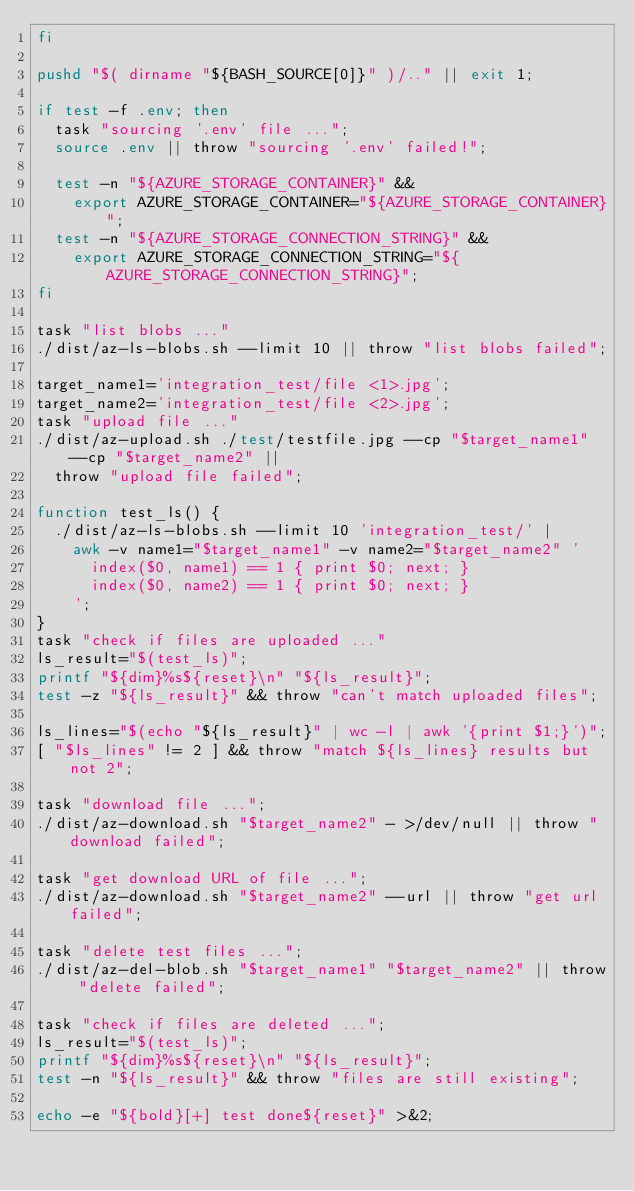Convert code to text. <code><loc_0><loc_0><loc_500><loc_500><_Bash_>fi

pushd "$( dirname "${BASH_SOURCE[0]}" )/.." || exit 1;

if test -f .env; then
  task "sourcing '.env' file ...";
  source .env || throw "sourcing '.env' failed!";

  test -n "${AZURE_STORAGE_CONTAINER}" &&
    export AZURE_STORAGE_CONTAINER="${AZURE_STORAGE_CONTAINER}";
  test -n "${AZURE_STORAGE_CONNECTION_STRING}" &&
    export AZURE_STORAGE_CONNECTION_STRING="${AZURE_STORAGE_CONNECTION_STRING}";
fi

task "list blobs ..."
./dist/az-ls-blobs.sh --limit 10 || throw "list blobs failed";

target_name1='integration_test/file <1>.jpg';
target_name2='integration_test/file <2>.jpg';
task "upload file ..."
./dist/az-upload.sh ./test/testfile.jpg --cp "$target_name1" --cp "$target_name2" ||
  throw "upload file failed";

function test_ls() {
  ./dist/az-ls-blobs.sh --limit 10 'integration_test/' |
    awk -v name1="$target_name1" -v name2="$target_name2" '
      index($0, name1) == 1 { print $0; next; }
      index($0, name2) == 1 { print $0; next; }
    ';
}
task "check if files are uploaded ..."
ls_result="$(test_ls)";
printf "${dim}%s${reset}\n" "${ls_result}";
test -z "${ls_result}" && throw "can't match uploaded files";

ls_lines="$(echo "${ls_result}" | wc -l | awk '{print $1;}')";
[ "$ls_lines" != 2 ] && throw "match ${ls_lines} results but not 2";

task "download file ...";
./dist/az-download.sh "$target_name2" - >/dev/null || throw "download failed";

task "get download URL of file ...";
./dist/az-download.sh "$target_name2" --url || throw "get url failed";

task "delete test files ...";
./dist/az-del-blob.sh "$target_name1" "$target_name2" || throw "delete failed";

task "check if files are deleted ...";
ls_result="$(test_ls)";
printf "${dim}%s${reset}\n" "${ls_result}";
test -n "${ls_result}" && throw "files are still existing";

echo -e "${bold}[+] test done${reset}" >&2;
</code> 